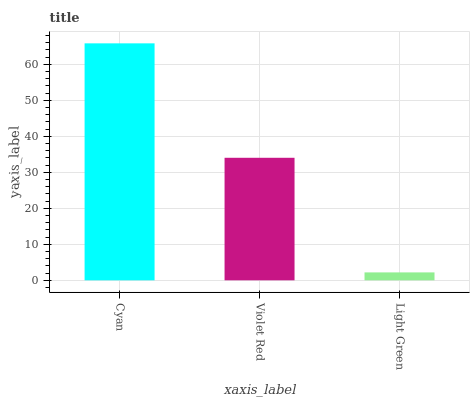Is Violet Red the minimum?
Answer yes or no. No. Is Violet Red the maximum?
Answer yes or no. No. Is Cyan greater than Violet Red?
Answer yes or no. Yes. Is Violet Red less than Cyan?
Answer yes or no. Yes. Is Violet Red greater than Cyan?
Answer yes or no. No. Is Cyan less than Violet Red?
Answer yes or no. No. Is Violet Red the high median?
Answer yes or no. Yes. Is Violet Red the low median?
Answer yes or no. Yes. Is Light Green the high median?
Answer yes or no. No. Is Cyan the low median?
Answer yes or no. No. 